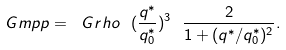Convert formula to latex. <formula><loc_0><loc_0><loc_500><loc_500>\ G m p p = \ G r h o \ ( \frac { q ^ { * } } { q _ { 0 } ^ { * } } ) ^ { 3 } \ \frac { 2 } { 1 + ( q ^ { * } / q ^ { * } _ { 0 } ) ^ { 2 } } .</formula> 